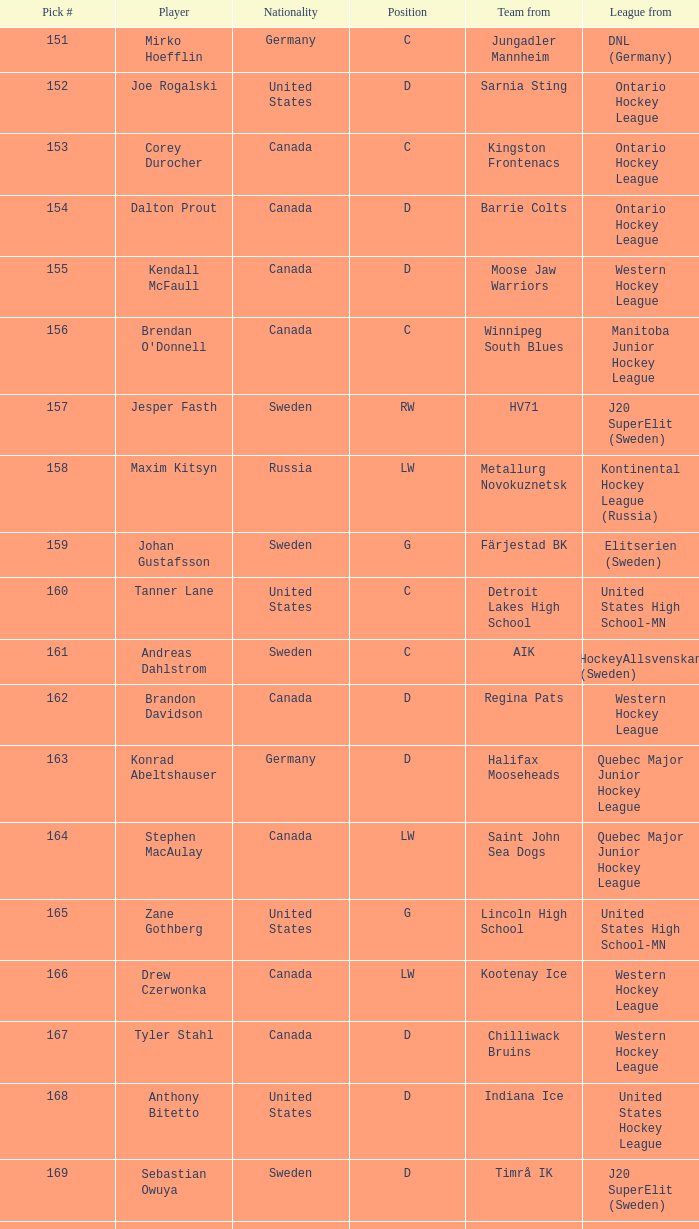What is the average pick # from the Quebec Major Junior Hockey League player Samuel Carrier? 176.0. 